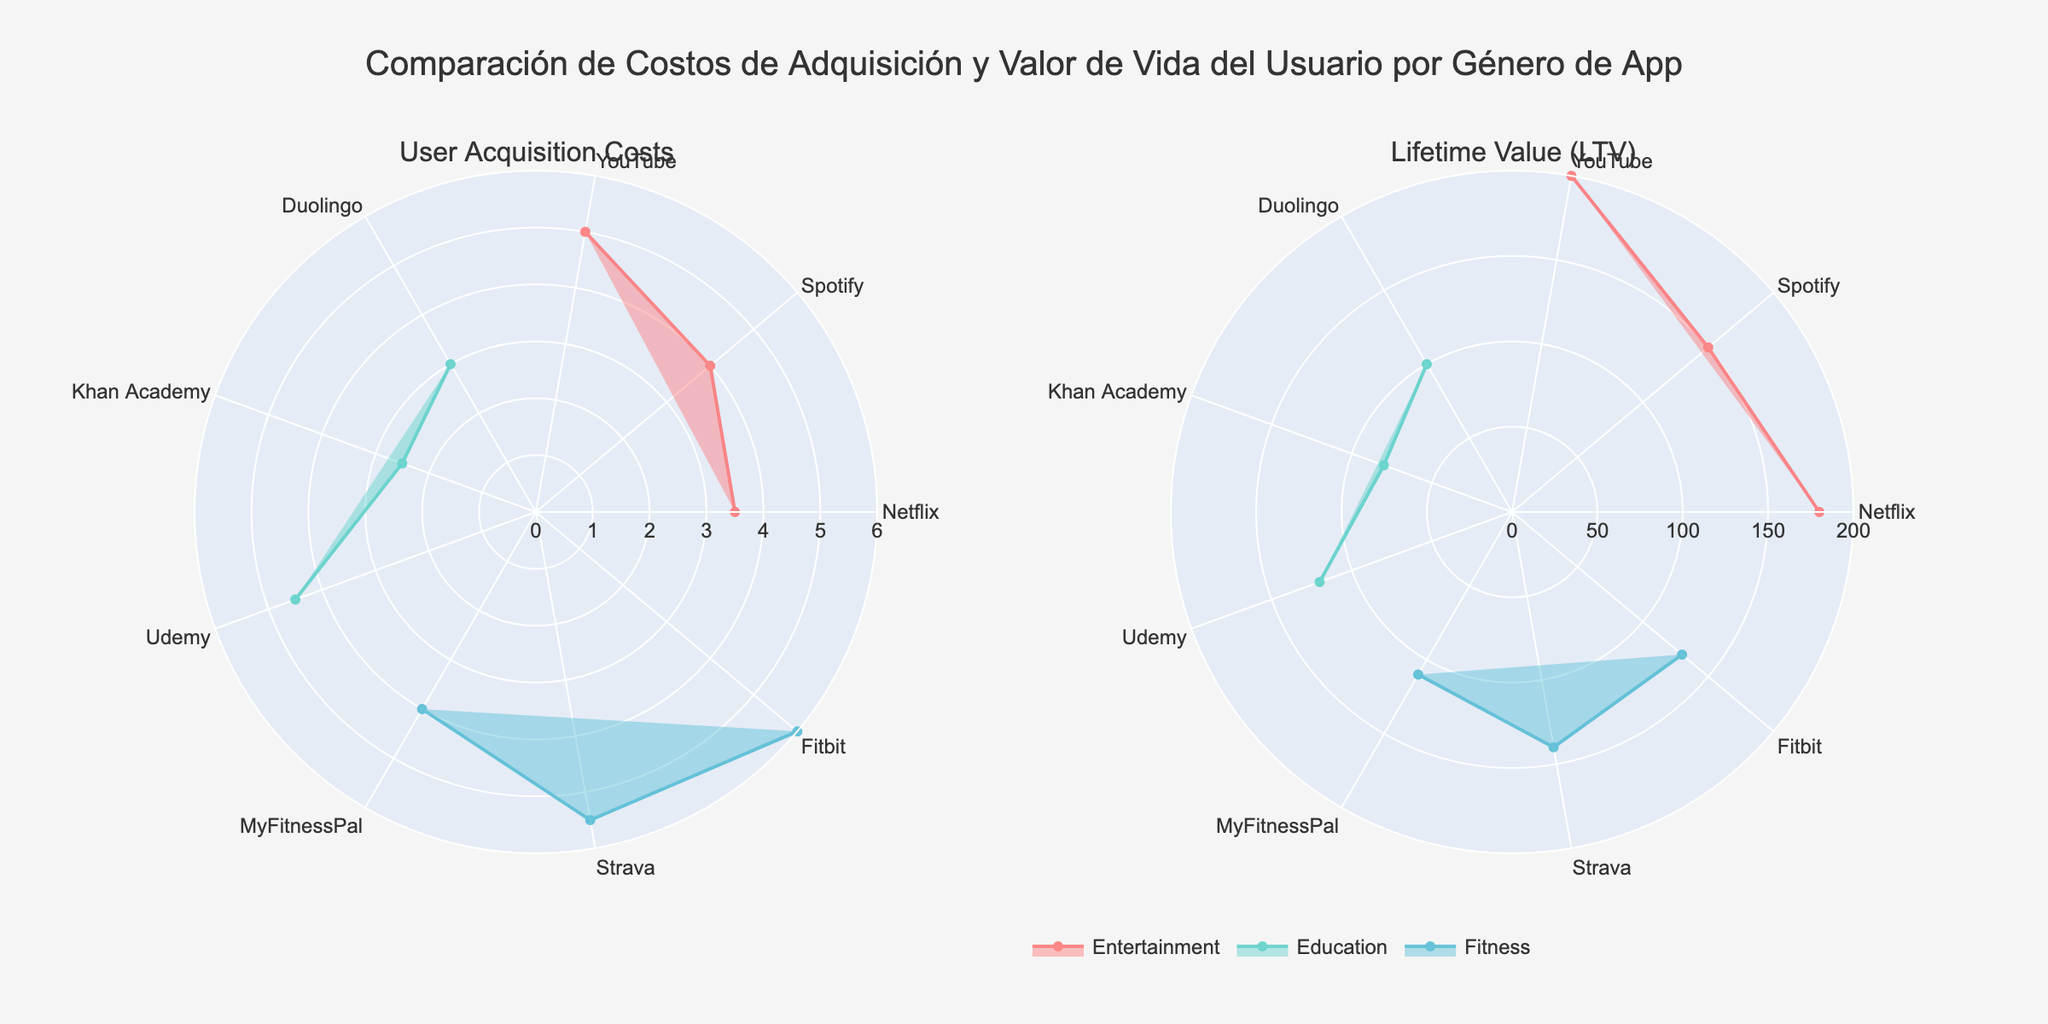Which app in the Entertainment genre has the highest user acquisition cost? By looking at the radar chart on the left for the User Acquisition Costs, among the Entertainment apps (Netflix, Spotify, YouTube), YouTube is the one with the highest value.
Answer: YouTube In the Fitness genre, which app has the lowest Lifetime Value (LTV)? By inspecting the radar chart on the right for Lifetime Value (LTV), among the Fitness apps (MyFitnessPal, Strava, Fitbit), MyFitnessPal has the lowest value.
Answer: MyFitnessPal What is the difference in Lifetime Value (LTV) between the most profitable app in the Education genre and the least profitable app in the Entertainment genre? Identify the app with the highest LTV in Education (Udemy with $120) and the app with the lowest LTV in Entertainment (Spotify with $150). Subtract the LTV of Spotify from Udemy's LTV: 120 - 150 = -30.
Answer: -30 By what percentage is YouTube's user acquisition cost higher compared to Fitbit's user acquisition cost? YouTube's cost is $5, and Fitbit's cost is $6. Percentage difference is calculated as ((5 - 6) / 6) * 100%.
Answer: -16.67% Which app genre generally has the highest average user acquisition cost? Calculate the average user acquisition costs for each genre (Entertainment: (3.5+4+5)/3=4.17, Education: (3+2.5+4.5)/3=3.33, Fitness: (4+5.5+6)/3=5.17). The genre with the highest value is Fitness.
Answer: Fitness Between Entertainment and Education genres, which has a larger range of Lifetime Value (LTV)? Range is calculated as the difference between the maximum and minimum LTV: Entertainment range is 200 - 150 = 50, Education range is 120 - 80 = 40. Therefore, Entertainment has a larger range.
Answer: Entertainment For the app with the highest user acquisition cost in each genre, which one has the highest Lifetime Value (LTV)? Identify the highest user acquisition cost in each genre (YouTube: $5, Udemy: $4.5, Fitbit: $6). Check their LTVs (YouTube: $200, Udemy: $120, Fitbit: $130). YouTube has the highest LTV.
Answer: YouTube How does the lifetime value of Khan Academy compare to the average lifetime value of the Fitness apps? Khan Academy's LTV is $80. The average LTV for Fitness apps is (110 + 140 + 130) / 3 = 126.67. Khan Academy's LTV is lower.
Answer: Lower 